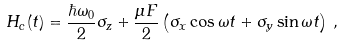<formula> <loc_0><loc_0><loc_500><loc_500>H _ { c } ( t ) = \frac { \hbar { \omega } _ { 0 } } { 2 } \sigma _ { z } + \frac { \mu F } { 2 } \left ( \sigma _ { x } \cos \omega t + \sigma _ { y } \sin \omega t \right ) \, ,</formula> 